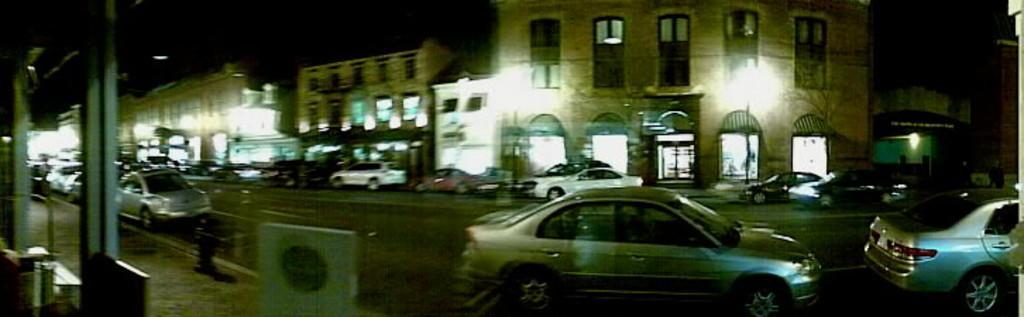Can you describe this image briefly? In this image we can see a glass. Behind the glass, we can see a pavement, buildings, lights and cars on the road. We can see some objects on the left side of the image. 